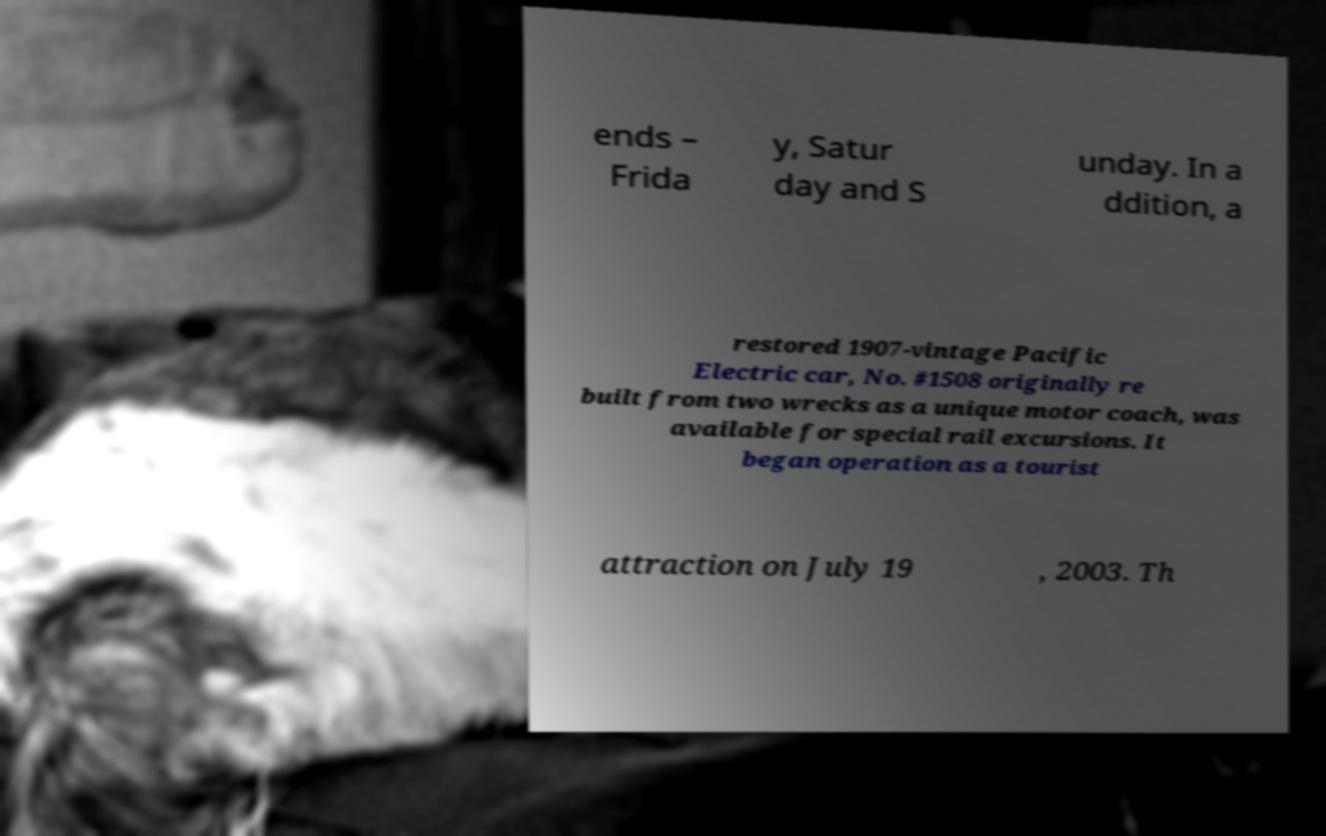Could you extract and type out the text from this image? ends – Frida y, Satur day and S unday. In a ddition, a restored 1907-vintage Pacific Electric car, No. #1508 originally re built from two wrecks as a unique motor coach, was available for special rail excursions. It began operation as a tourist attraction on July 19 , 2003. Th 